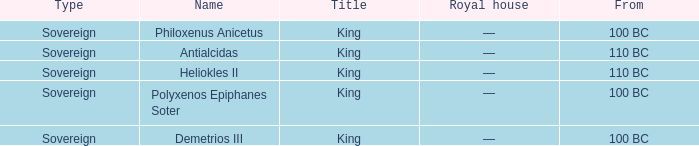Which royal house corresponds to Polyxenos Epiphanes Soter? —. 